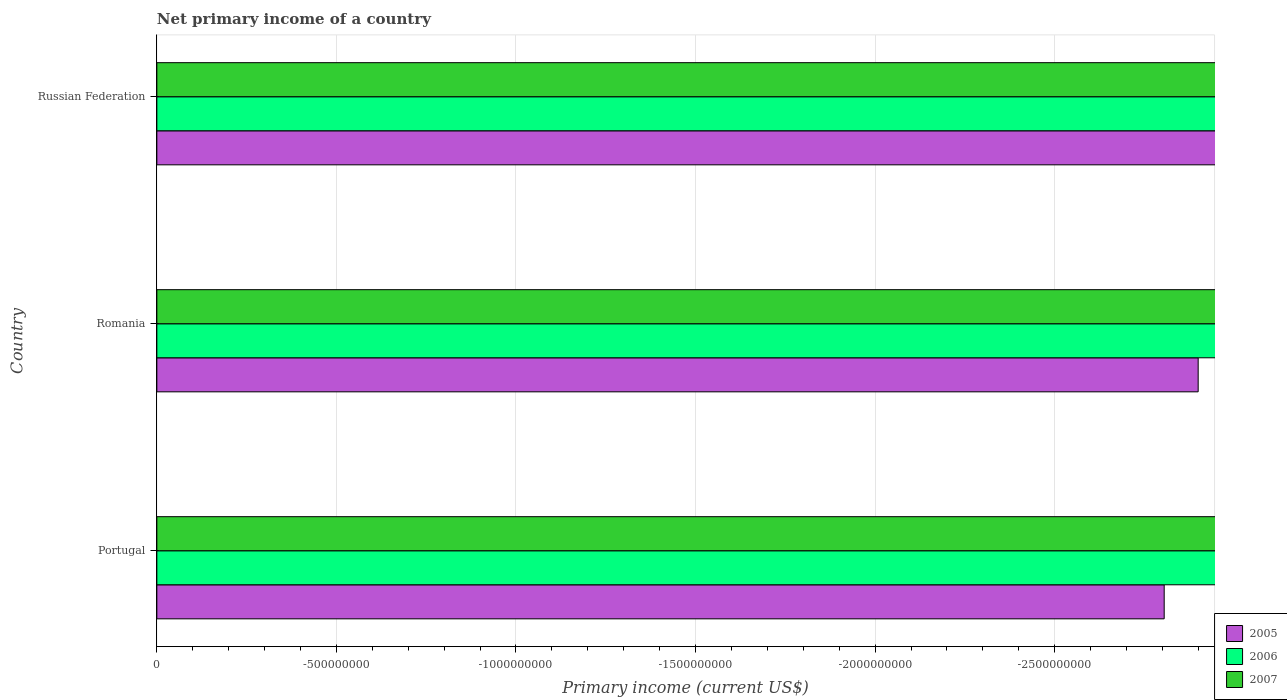Are the number of bars on each tick of the Y-axis equal?
Keep it short and to the point. Yes. What is the label of the 1st group of bars from the top?
Ensure brevity in your answer.  Russian Federation. In how many cases, is the number of bars for a given country not equal to the number of legend labels?
Your answer should be very brief. 3. What is the primary income in 2006 in Russian Federation?
Offer a very short reply. 0. Across all countries, what is the minimum primary income in 2007?
Your answer should be very brief. 0. What is the average primary income in 2005 per country?
Make the answer very short. 0. In how many countries, is the primary income in 2007 greater than -700000000 US$?
Offer a terse response. 0. In how many countries, is the primary income in 2005 greater than the average primary income in 2005 taken over all countries?
Provide a succinct answer. 0. What is the difference between two consecutive major ticks on the X-axis?
Keep it short and to the point. 5.00e+08. Does the graph contain any zero values?
Your answer should be very brief. Yes. Does the graph contain grids?
Provide a succinct answer. Yes. Where does the legend appear in the graph?
Give a very brief answer. Bottom right. How many legend labels are there?
Your answer should be compact. 3. How are the legend labels stacked?
Keep it short and to the point. Vertical. What is the title of the graph?
Your answer should be compact. Net primary income of a country. Does "1979" appear as one of the legend labels in the graph?
Keep it short and to the point. No. What is the label or title of the X-axis?
Make the answer very short. Primary income (current US$). What is the label or title of the Y-axis?
Offer a very short reply. Country. What is the Primary income (current US$) in 2005 in Portugal?
Offer a very short reply. 0. What is the Primary income (current US$) in 2005 in Romania?
Ensure brevity in your answer.  0. What is the Primary income (current US$) in 2006 in Romania?
Your answer should be very brief. 0. What is the Primary income (current US$) in 2007 in Romania?
Ensure brevity in your answer.  0. What is the Primary income (current US$) of 2005 in Russian Federation?
Your response must be concise. 0. What is the Primary income (current US$) in 2007 in Russian Federation?
Make the answer very short. 0. What is the total Primary income (current US$) in 2006 in the graph?
Provide a succinct answer. 0. What is the total Primary income (current US$) of 2007 in the graph?
Your answer should be compact. 0. What is the average Primary income (current US$) of 2007 per country?
Ensure brevity in your answer.  0. 